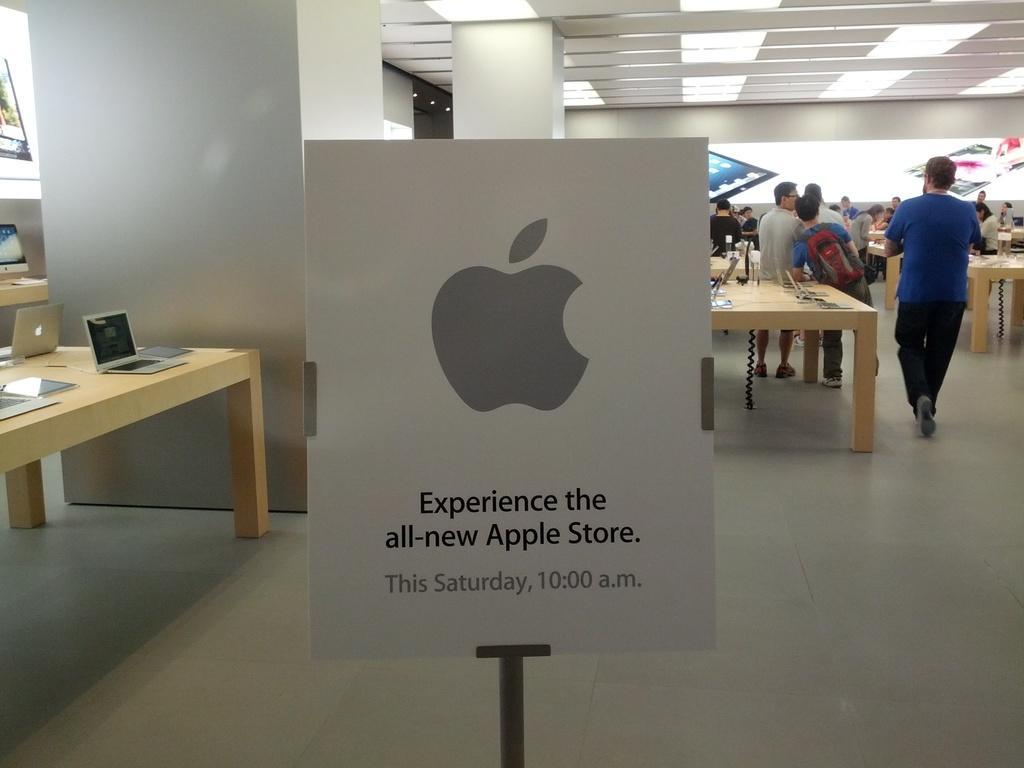Please provide a concise description of this image. In this image I can see number of people are standing, I can also see few tables and laptops on it. Here I can see a board. 